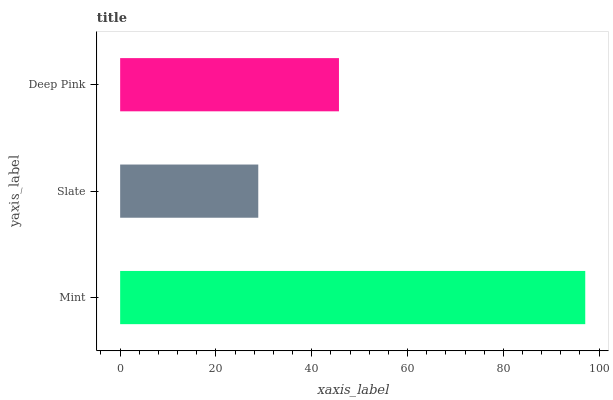Is Slate the minimum?
Answer yes or no. Yes. Is Mint the maximum?
Answer yes or no. Yes. Is Deep Pink the minimum?
Answer yes or no. No. Is Deep Pink the maximum?
Answer yes or no. No. Is Deep Pink greater than Slate?
Answer yes or no. Yes. Is Slate less than Deep Pink?
Answer yes or no. Yes. Is Slate greater than Deep Pink?
Answer yes or no. No. Is Deep Pink less than Slate?
Answer yes or no. No. Is Deep Pink the high median?
Answer yes or no. Yes. Is Deep Pink the low median?
Answer yes or no. Yes. Is Slate the high median?
Answer yes or no. No. Is Mint the low median?
Answer yes or no. No. 